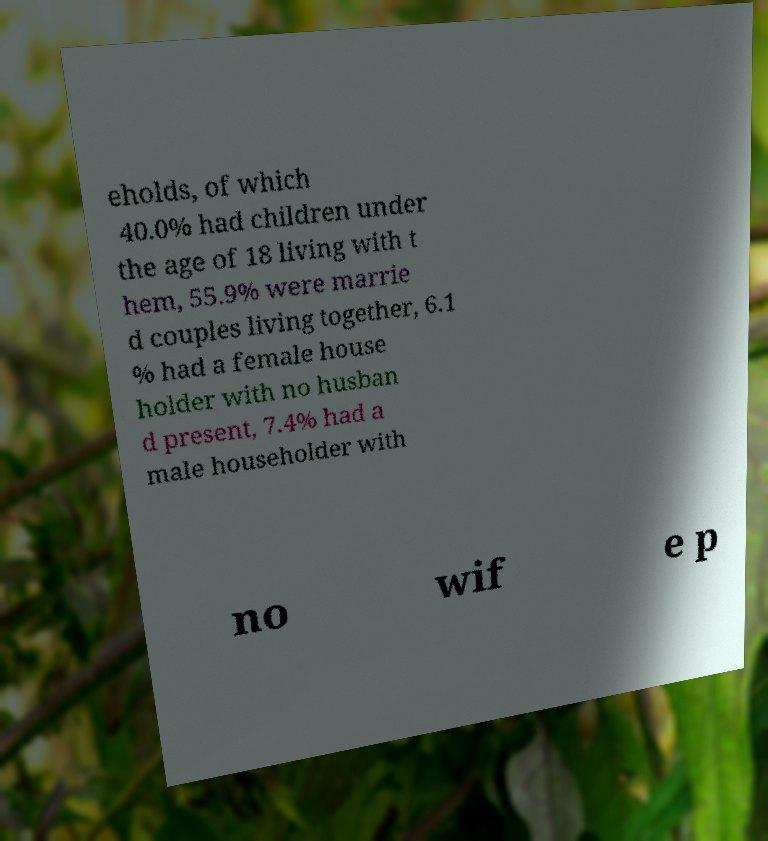What messages or text are displayed in this image? I need them in a readable, typed format. eholds, of which 40.0% had children under the age of 18 living with t hem, 55.9% were marrie d couples living together, 6.1 % had a female house holder with no husban d present, 7.4% had a male householder with no wif e p 